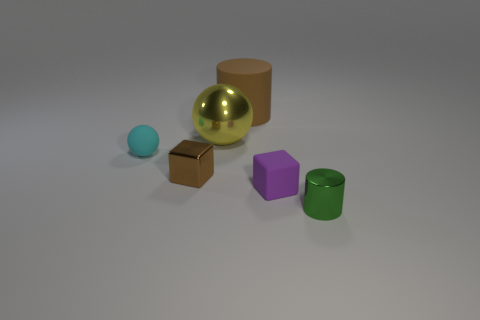How many objects have a reflective surface? There are two objects with a reflective surface: the small shiny cube and the large gold sphere. 